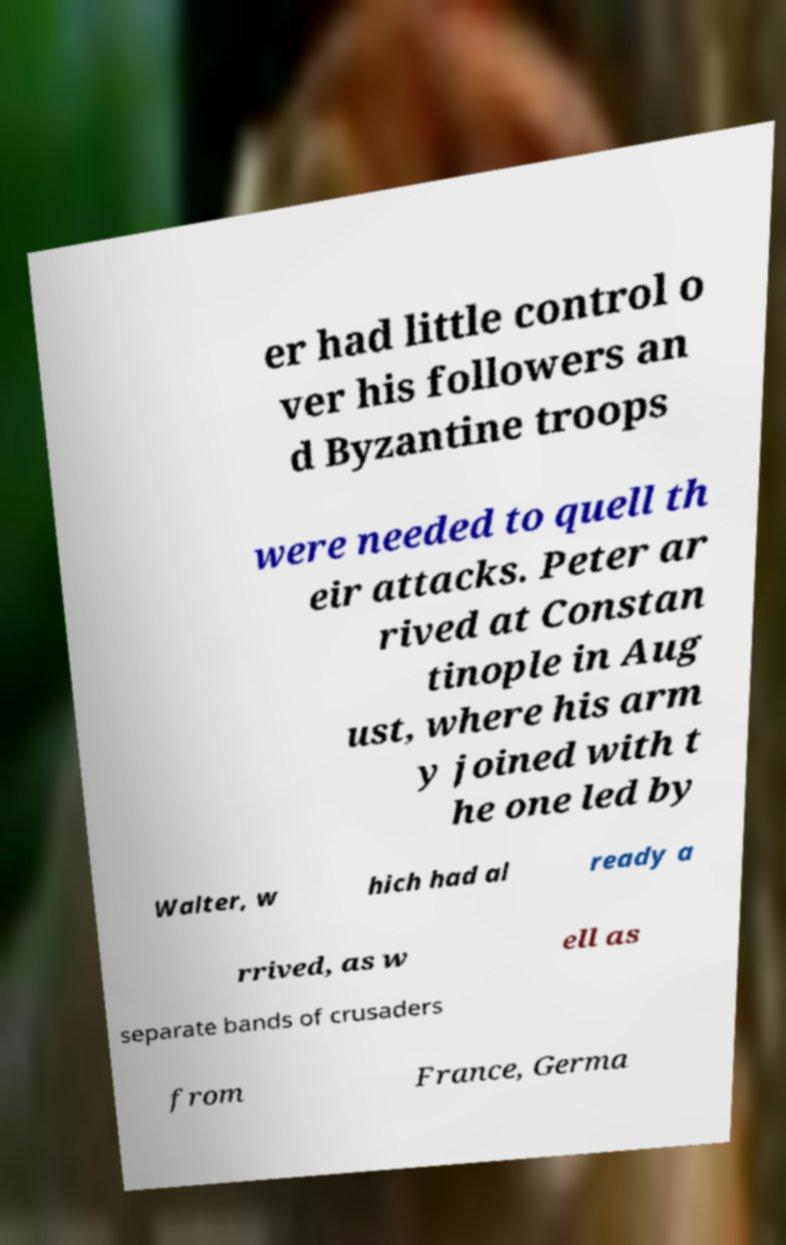There's text embedded in this image that I need extracted. Can you transcribe it verbatim? er had little control o ver his followers an d Byzantine troops were needed to quell th eir attacks. Peter ar rived at Constan tinople in Aug ust, where his arm y joined with t he one led by Walter, w hich had al ready a rrived, as w ell as separate bands of crusaders from France, Germa 